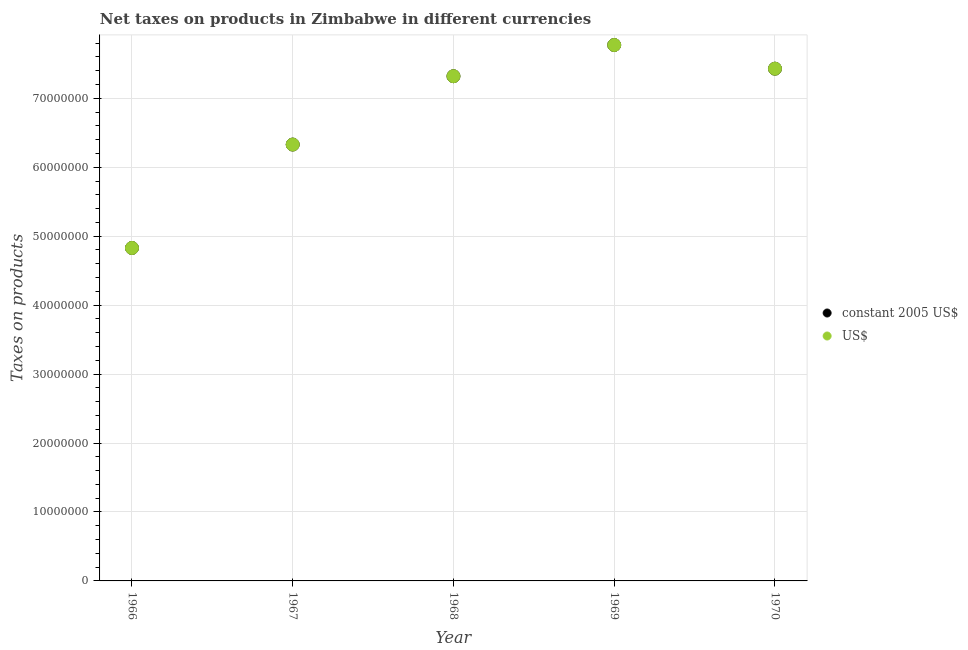How many different coloured dotlines are there?
Make the answer very short. 2. What is the net taxes in us$ in 1970?
Your answer should be very brief. 7.43e+07. Across all years, what is the maximum net taxes in constant 2005 us$?
Keep it short and to the point. 7.77e+07. Across all years, what is the minimum net taxes in constant 2005 us$?
Make the answer very short. 4.83e+07. In which year was the net taxes in constant 2005 us$ maximum?
Offer a terse response. 1969. In which year was the net taxes in us$ minimum?
Your response must be concise. 1966. What is the total net taxes in us$ in the graph?
Your answer should be compact. 3.37e+08. What is the difference between the net taxes in constant 2005 us$ in 1966 and that in 1968?
Offer a very short reply. -2.49e+07. What is the difference between the net taxes in constant 2005 us$ in 1968 and the net taxes in us$ in 1969?
Ensure brevity in your answer.  -4.52e+06. What is the average net taxes in constant 2005 us$ per year?
Make the answer very short. 6.74e+07. In how many years, is the net taxes in constant 2005 us$ greater than 6000000 units?
Your answer should be compact. 5. What is the ratio of the net taxes in constant 2005 us$ in 1966 to that in 1970?
Ensure brevity in your answer.  0.65. What is the difference between the highest and the second highest net taxes in us$?
Your answer should be very brief. 3.43e+06. What is the difference between the highest and the lowest net taxes in constant 2005 us$?
Your answer should be compact. 2.94e+07. In how many years, is the net taxes in us$ greater than the average net taxes in us$ taken over all years?
Your response must be concise. 3. Is the net taxes in us$ strictly greater than the net taxes in constant 2005 us$ over the years?
Your answer should be very brief. No. Is the net taxes in constant 2005 us$ strictly less than the net taxes in us$ over the years?
Your response must be concise. No. How many years are there in the graph?
Provide a short and direct response. 5. Does the graph contain any zero values?
Keep it short and to the point. No. Does the graph contain grids?
Offer a terse response. Yes. What is the title of the graph?
Your answer should be very brief. Net taxes on products in Zimbabwe in different currencies. Does "Urban Population" appear as one of the legend labels in the graph?
Ensure brevity in your answer.  No. What is the label or title of the X-axis?
Give a very brief answer. Year. What is the label or title of the Y-axis?
Your answer should be compact. Taxes on products. What is the Taxes on products of constant 2005 US$ in 1966?
Offer a very short reply. 4.83e+07. What is the Taxes on products in US$ in 1966?
Provide a short and direct response. 4.83e+07. What is the Taxes on products in constant 2005 US$ in 1967?
Keep it short and to the point. 6.33e+07. What is the Taxes on products of US$ in 1967?
Keep it short and to the point. 6.33e+07. What is the Taxes on products of constant 2005 US$ in 1968?
Your answer should be very brief. 7.32e+07. What is the Taxes on products of US$ in 1968?
Make the answer very short. 7.32e+07. What is the Taxes on products of constant 2005 US$ in 1969?
Your response must be concise. 7.77e+07. What is the Taxes on products in US$ in 1969?
Offer a terse response. 7.77e+07. What is the Taxes on products in constant 2005 US$ in 1970?
Provide a short and direct response. 7.43e+07. What is the Taxes on products in US$ in 1970?
Your answer should be compact. 7.43e+07. Across all years, what is the maximum Taxes on products of constant 2005 US$?
Provide a succinct answer. 7.77e+07. Across all years, what is the maximum Taxes on products of US$?
Give a very brief answer. 7.77e+07. Across all years, what is the minimum Taxes on products of constant 2005 US$?
Keep it short and to the point. 4.83e+07. Across all years, what is the minimum Taxes on products of US$?
Provide a short and direct response. 4.83e+07. What is the total Taxes on products in constant 2005 US$ in the graph?
Ensure brevity in your answer.  3.37e+08. What is the total Taxes on products of US$ in the graph?
Your answer should be compact. 3.37e+08. What is the difference between the Taxes on products of constant 2005 US$ in 1966 and that in 1967?
Make the answer very short. -1.50e+07. What is the difference between the Taxes on products of US$ in 1966 and that in 1967?
Provide a succinct answer. -1.50e+07. What is the difference between the Taxes on products in constant 2005 US$ in 1966 and that in 1968?
Your answer should be compact. -2.49e+07. What is the difference between the Taxes on products in US$ in 1966 and that in 1968?
Your answer should be compact. -2.49e+07. What is the difference between the Taxes on products of constant 2005 US$ in 1966 and that in 1969?
Provide a succinct answer. -2.94e+07. What is the difference between the Taxes on products of US$ in 1966 and that in 1969?
Your answer should be very brief. -2.94e+07. What is the difference between the Taxes on products of constant 2005 US$ in 1966 and that in 1970?
Ensure brevity in your answer.  -2.60e+07. What is the difference between the Taxes on products of US$ in 1966 and that in 1970?
Provide a short and direct response. -2.60e+07. What is the difference between the Taxes on products in constant 2005 US$ in 1967 and that in 1968?
Provide a succinct answer. -9.91e+06. What is the difference between the Taxes on products of US$ in 1967 and that in 1968?
Provide a short and direct response. -9.91e+06. What is the difference between the Taxes on products of constant 2005 US$ in 1967 and that in 1969?
Offer a terse response. -1.44e+07. What is the difference between the Taxes on products of US$ in 1967 and that in 1969?
Make the answer very short. -1.44e+07. What is the difference between the Taxes on products of constant 2005 US$ in 1967 and that in 1970?
Your answer should be compact. -1.10e+07. What is the difference between the Taxes on products in US$ in 1967 and that in 1970?
Your response must be concise. -1.10e+07. What is the difference between the Taxes on products of constant 2005 US$ in 1968 and that in 1969?
Ensure brevity in your answer.  -4.52e+06. What is the difference between the Taxes on products in US$ in 1968 and that in 1969?
Offer a terse response. -4.52e+06. What is the difference between the Taxes on products of constant 2005 US$ in 1968 and that in 1970?
Ensure brevity in your answer.  -1.09e+06. What is the difference between the Taxes on products in US$ in 1968 and that in 1970?
Make the answer very short. -1.09e+06. What is the difference between the Taxes on products of constant 2005 US$ in 1969 and that in 1970?
Offer a very short reply. 3.43e+06. What is the difference between the Taxes on products in US$ in 1969 and that in 1970?
Provide a short and direct response. 3.43e+06. What is the difference between the Taxes on products in constant 2005 US$ in 1966 and the Taxes on products in US$ in 1967?
Make the answer very short. -1.50e+07. What is the difference between the Taxes on products of constant 2005 US$ in 1966 and the Taxes on products of US$ in 1968?
Give a very brief answer. -2.49e+07. What is the difference between the Taxes on products in constant 2005 US$ in 1966 and the Taxes on products in US$ in 1969?
Your answer should be compact. -2.94e+07. What is the difference between the Taxes on products of constant 2005 US$ in 1966 and the Taxes on products of US$ in 1970?
Provide a short and direct response. -2.60e+07. What is the difference between the Taxes on products of constant 2005 US$ in 1967 and the Taxes on products of US$ in 1968?
Your answer should be compact. -9.91e+06. What is the difference between the Taxes on products of constant 2005 US$ in 1967 and the Taxes on products of US$ in 1969?
Provide a short and direct response. -1.44e+07. What is the difference between the Taxes on products of constant 2005 US$ in 1967 and the Taxes on products of US$ in 1970?
Give a very brief answer. -1.10e+07. What is the difference between the Taxes on products of constant 2005 US$ in 1968 and the Taxes on products of US$ in 1969?
Make the answer very short. -4.52e+06. What is the difference between the Taxes on products of constant 2005 US$ in 1968 and the Taxes on products of US$ in 1970?
Ensure brevity in your answer.  -1.09e+06. What is the difference between the Taxes on products in constant 2005 US$ in 1969 and the Taxes on products in US$ in 1970?
Give a very brief answer. 3.43e+06. What is the average Taxes on products of constant 2005 US$ per year?
Provide a succinct answer. 6.74e+07. What is the average Taxes on products in US$ per year?
Offer a terse response. 6.74e+07. In the year 1968, what is the difference between the Taxes on products of constant 2005 US$ and Taxes on products of US$?
Provide a succinct answer. 0. What is the ratio of the Taxes on products in constant 2005 US$ in 1966 to that in 1967?
Ensure brevity in your answer.  0.76. What is the ratio of the Taxes on products in US$ in 1966 to that in 1967?
Give a very brief answer. 0.76. What is the ratio of the Taxes on products in constant 2005 US$ in 1966 to that in 1968?
Give a very brief answer. 0.66. What is the ratio of the Taxes on products in US$ in 1966 to that in 1968?
Give a very brief answer. 0.66. What is the ratio of the Taxes on products of constant 2005 US$ in 1966 to that in 1969?
Offer a very short reply. 0.62. What is the ratio of the Taxes on products of US$ in 1966 to that in 1969?
Offer a terse response. 0.62. What is the ratio of the Taxes on products in constant 2005 US$ in 1966 to that in 1970?
Give a very brief answer. 0.65. What is the ratio of the Taxes on products of US$ in 1966 to that in 1970?
Provide a short and direct response. 0.65. What is the ratio of the Taxes on products of constant 2005 US$ in 1967 to that in 1968?
Give a very brief answer. 0.86. What is the ratio of the Taxes on products in US$ in 1967 to that in 1968?
Provide a short and direct response. 0.86. What is the ratio of the Taxes on products of constant 2005 US$ in 1967 to that in 1969?
Keep it short and to the point. 0.81. What is the ratio of the Taxes on products of US$ in 1967 to that in 1969?
Your answer should be very brief. 0.81. What is the ratio of the Taxes on products of constant 2005 US$ in 1967 to that in 1970?
Provide a short and direct response. 0.85. What is the ratio of the Taxes on products in US$ in 1967 to that in 1970?
Provide a short and direct response. 0.85. What is the ratio of the Taxes on products of constant 2005 US$ in 1968 to that in 1969?
Give a very brief answer. 0.94. What is the ratio of the Taxes on products in US$ in 1968 to that in 1969?
Make the answer very short. 0.94. What is the ratio of the Taxes on products in constant 2005 US$ in 1969 to that in 1970?
Provide a succinct answer. 1.05. What is the ratio of the Taxes on products in US$ in 1969 to that in 1970?
Keep it short and to the point. 1.05. What is the difference between the highest and the second highest Taxes on products of constant 2005 US$?
Provide a short and direct response. 3.43e+06. What is the difference between the highest and the second highest Taxes on products in US$?
Your answer should be compact. 3.43e+06. What is the difference between the highest and the lowest Taxes on products in constant 2005 US$?
Provide a succinct answer. 2.94e+07. What is the difference between the highest and the lowest Taxes on products in US$?
Your answer should be very brief. 2.94e+07. 